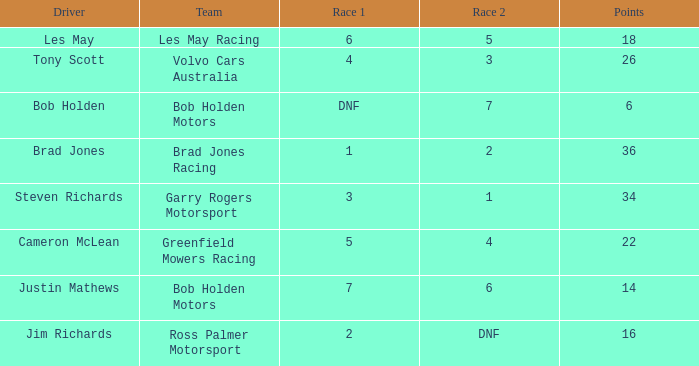Which team received 4 in race 1? Volvo Cars Australia. 